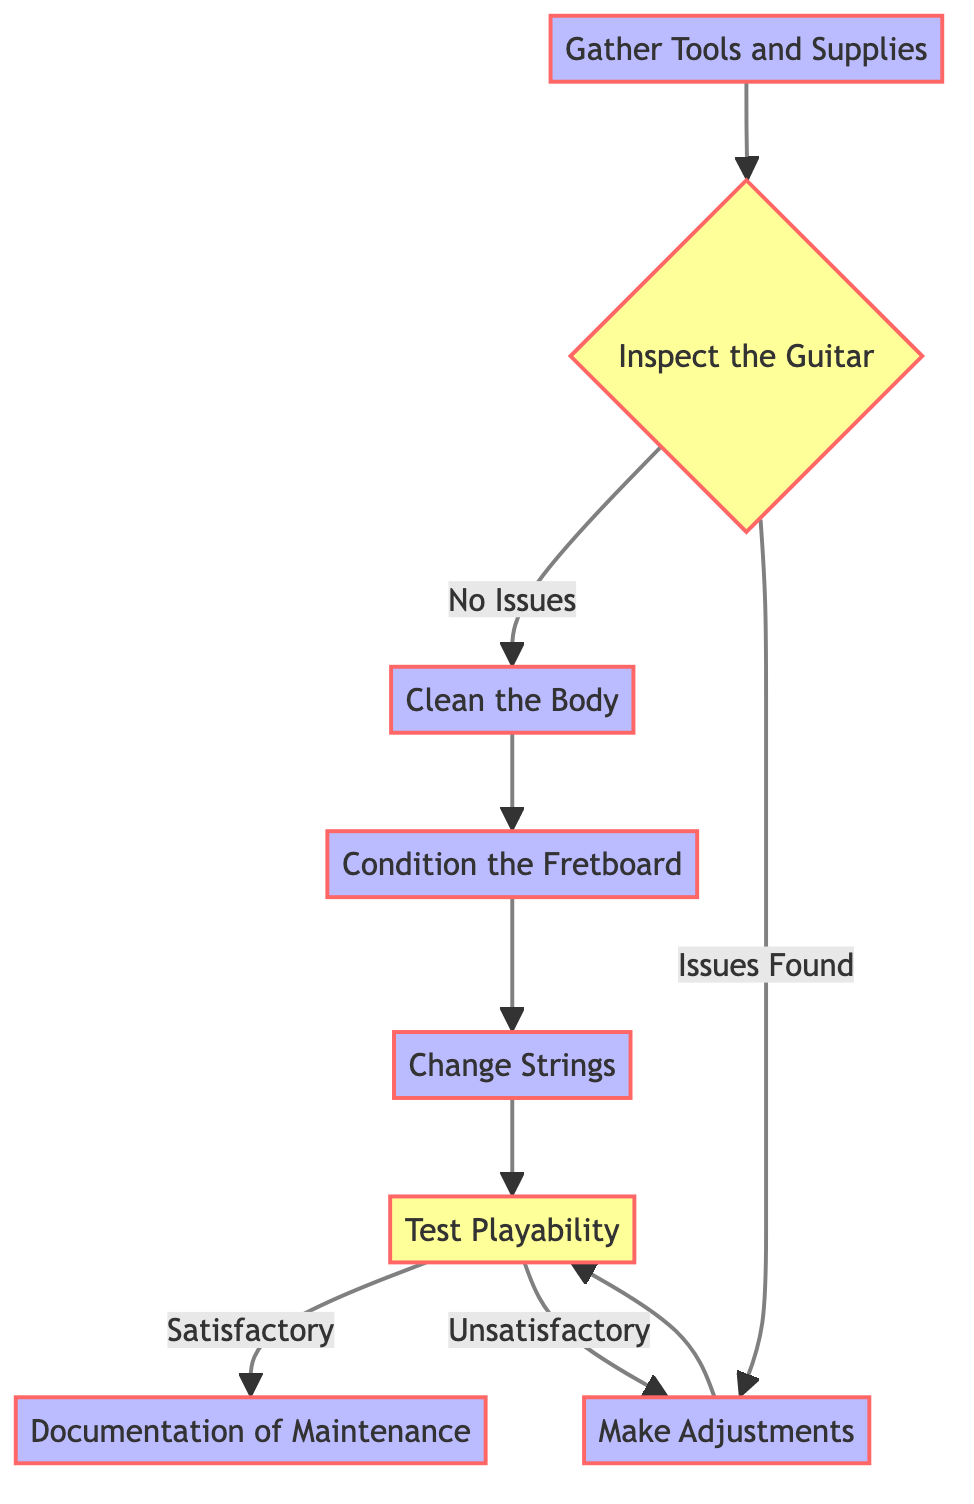What is the first step in the maintenance routine? The first node in the flow chart is "Gather Tools and Supplies," indicating that this is the initial step to start the maintenance routine.
Answer: Gather Tools and Supplies How many decision points are in the diagram? By counting the diamond-shaped nodes in the flow chart, we see there are two decision points: one after inspecting the guitar and one after testing playability.
Answer: 2 What action follows cleaning the body? After "Clean the Body," the next node is "Condition the Fretboard," making it the direct follow-up action.
Answer: Condition the Fretboard What happens if issues are found during inspection? If issues are found during the "Inspect the Guitar" step, the flow leads to "Make Adjustments," meaning adjustments need to be made in response to the inspection results.
Answer: Make Adjustments How many steps are taken if the playability test is satisfactory? If the playability test is satisfactory, the flow proceeds directly to "Documentation of Maintenance," which counts as one additional step after the test. Thus, that totals to 6 steps from the start to this point.
Answer: 6 steps What is the role of "Documentation of Maintenance"? At the end of the flowchart, "Documentation of Maintenance" indicates keeping a record of all maintenance performed as part of the routine, serving a critical function in tracking care provided to the instruments.
Answer: Keeping a record What is the outcome if playability is unsatisfactory? If playability is unsatisfactory after testing, the flow loops back to "Make Adjustments," which indicates that adjustments are necessary before re-testing playability.
Answer: Make Adjustments Which step occurs after changing the strings? After "Change Strings," the flow leads to the next action "Test Playability," which is the subsequent step in the maintenance routine.
Answer: Test Playability 